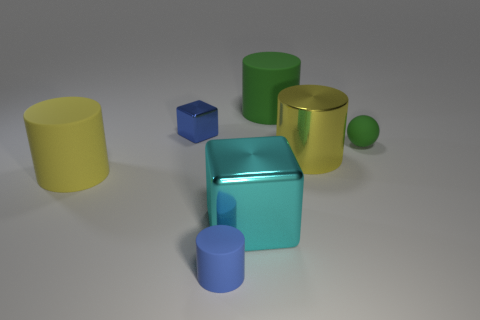Subtract 1 cylinders. How many cylinders are left? 3 Subtract all purple cylinders. Subtract all purple spheres. How many cylinders are left? 4 Add 3 large blue blocks. How many objects exist? 10 Subtract all balls. How many objects are left? 6 Add 2 cyan objects. How many cyan objects exist? 3 Subtract 1 green balls. How many objects are left? 6 Subtract all big green spheres. Subtract all large shiny cylinders. How many objects are left? 6 Add 7 matte cylinders. How many matte cylinders are left? 10 